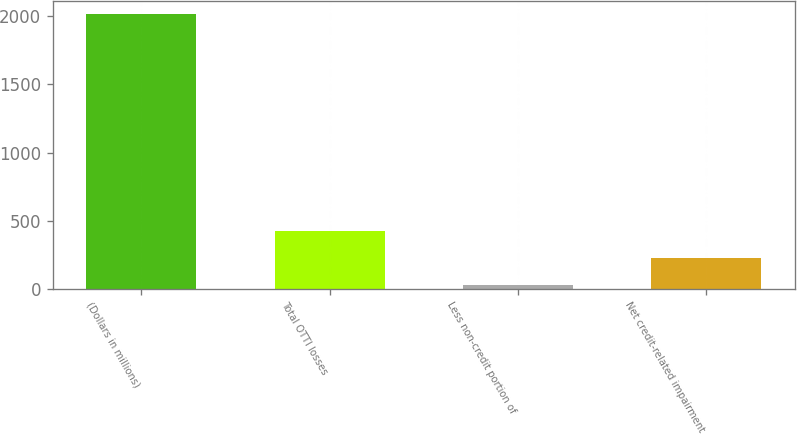Convert chart. <chart><loc_0><loc_0><loc_500><loc_500><bar_chart><fcel>(Dollars in millions)<fcel>Total OTTI losses<fcel>Less non-credit portion of<fcel>Net credit-related impairment<nl><fcel>2015<fcel>427<fcel>30<fcel>228.5<nl></chart> 